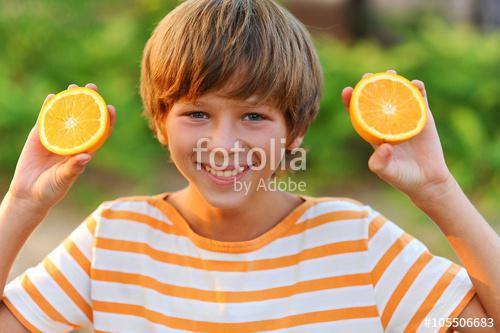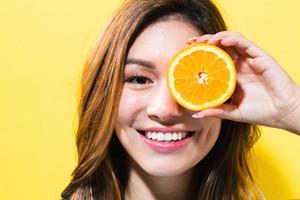The first image is the image on the left, the second image is the image on the right. Given the left and right images, does the statement "One person is holding an orange slice over at least one of their eyes." hold true? Answer yes or no. Yes. The first image is the image on the left, the second image is the image on the right. Analyze the images presented: Is the assertion "In one image, a woman is holding one or more slices of orange to her face, while a child in a second image is holding up an orange or part of one in each hand." valid? Answer yes or no. Yes. 